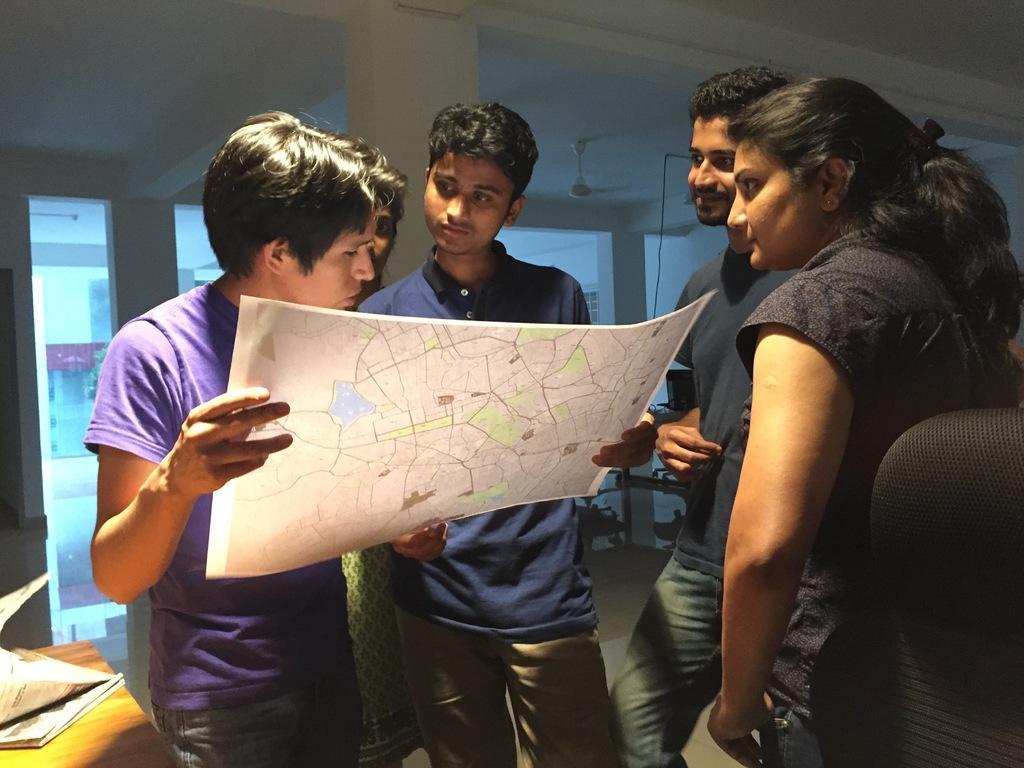Can you describe this image briefly? In this image, there are a few people. Among them, some people are holding an object. We can see the ground and the roof with a fan. We can also see a table with some objects on the bottom left corner. We can also see a black colored object on the right. There are a few pillars. We can see some glass. 